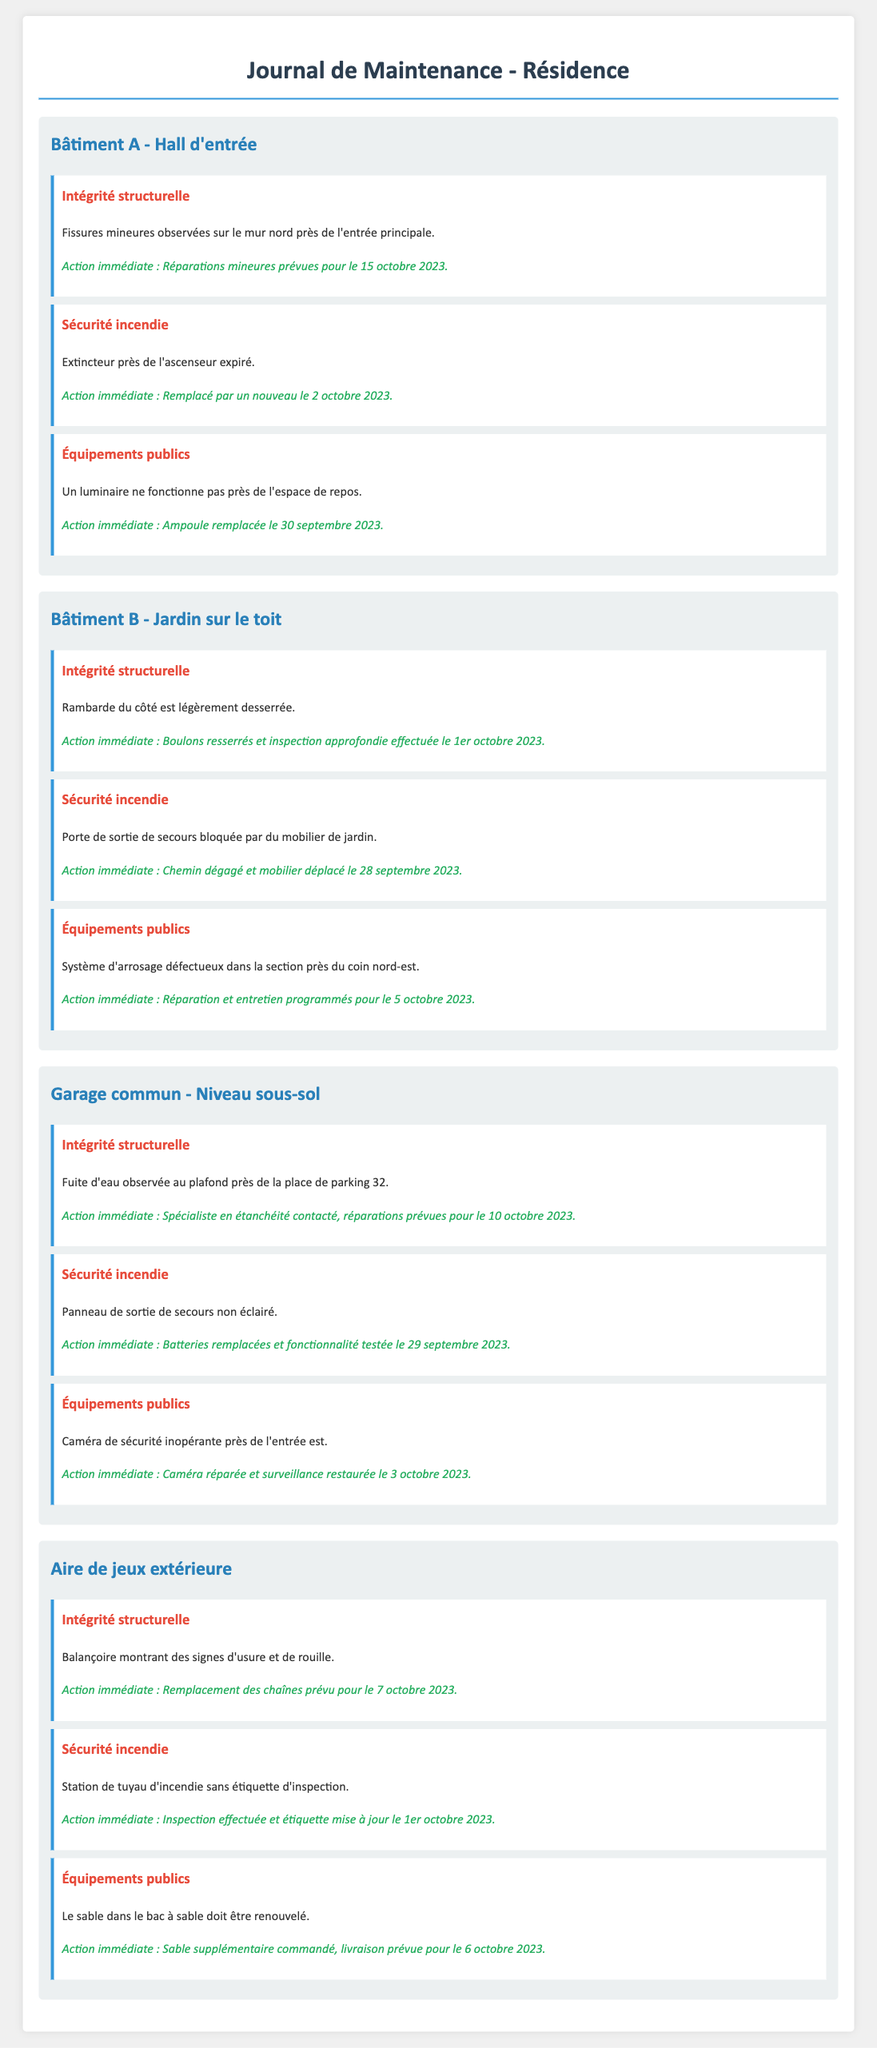Quel est le problème d'intégrité structurelle dans le Hall d'entrée ? Fissures mineures sur le mur nord près de l'entrée principale.
Answer: Fissures mineures Quelle action immédiate a été prise pour le luminaire défectueux dans le Hall d'entrée ? L'ampoule a été remplacée le 30 septembre 2023.
Answer: Ampoule remplacée Quand la rambarde du côté est de Bâtiment B a-t-elle été inspectée ? Un inspection approfondie a été faite le 1er octobre 2023.
Answer: 1er octobre 2023 Quel type de problème a été observé au plafond du garage commun ? Une fuite d'eau près de la place de parking 32.
Answer: Fuite d'eau Quel équipement public doit être renouvelé dans l'aire de jeux extérieure ? Le sable dans le bac à sable.
Answer: Sable Combien de jours après l'identification de problèmes la caméra de sécurité a-t-elle été réparée ? La caméra a été réparée le 3 octobre 2023, après avoir été identifiée dans le log le 29 septembre.
Answer: 4 jours Quelle action a été prise pour la porte de sortie de secours au Jardin sur le toit ? Le chemin a été dégagé et le mobilier déplacé le 28 septembre 2023.
Answer: Mobilier déplacé Quel problème a été identifié lié à la sécurité incendie dans le garage commun ? Le panneau de sortie de secours n'était pas éclairé.
Answer: Non éclairé 